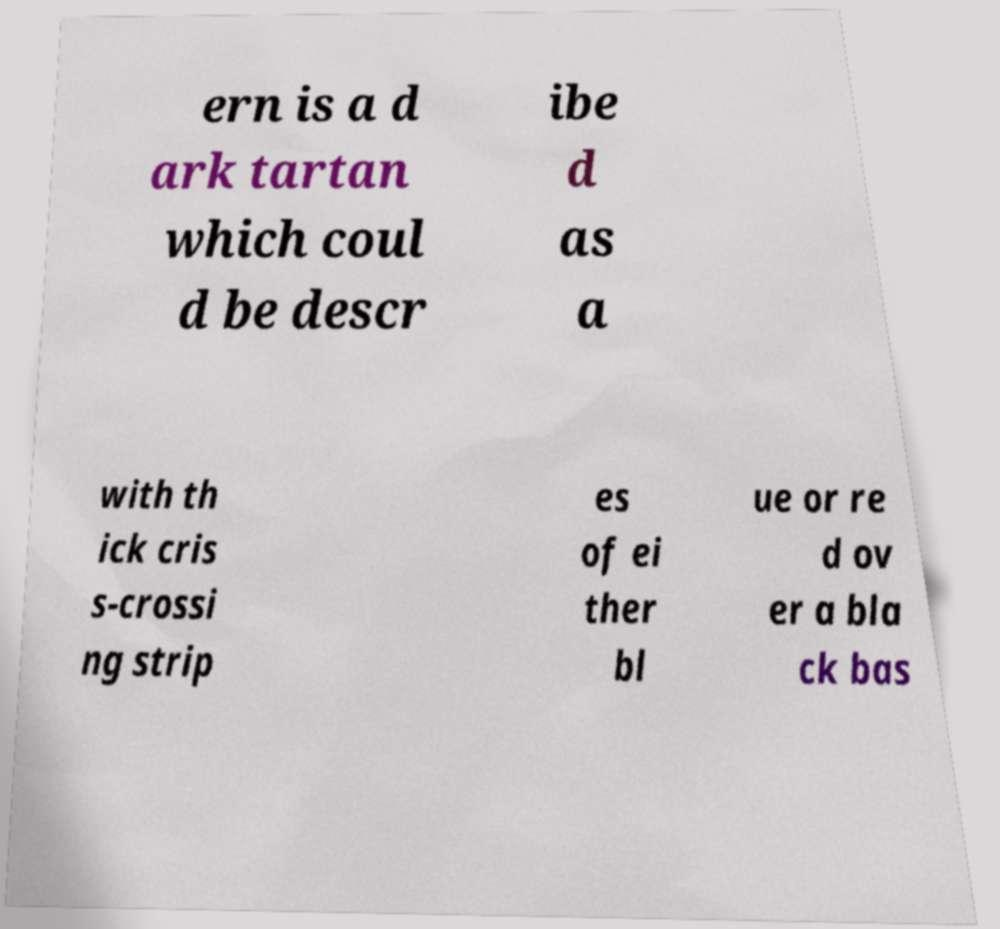Can you accurately transcribe the text from the provided image for me? ern is a d ark tartan which coul d be descr ibe d as a with th ick cris s-crossi ng strip es of ei ther bl ue or re d ov er a bla ck bas 